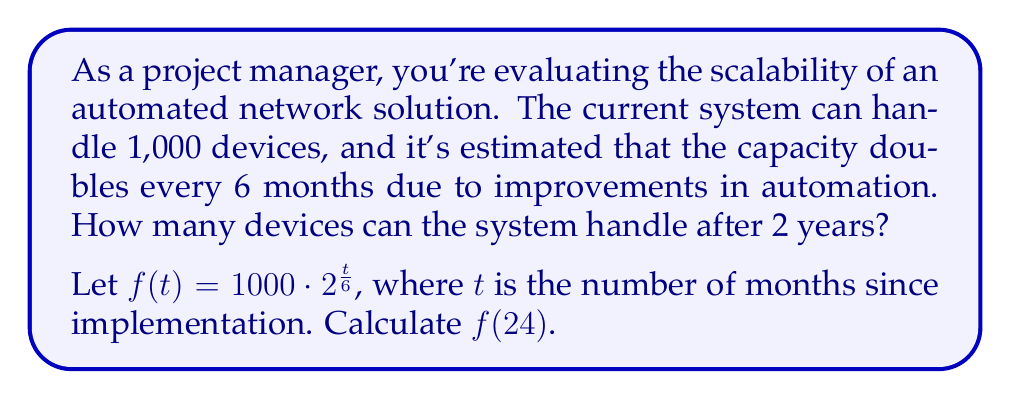Give your solution to this math problem. To solve this problem, we'll follow these steps:

1) We're given the function $f(t) = 1000 \cdot 2^{\frac{t}{6}}$, where:
   - 1000 is the initial capacity
   - 2 is the growth factor (capacity doubles)
   - $\frac{t}{6}$ represents the number of doubling periods (every 6 months)

2) We need to calculate $f(24)$, as 24 months = 2 years:

   $f(24) = 1000 \cdot 2^{\frac{24}{6}}$

3) Simplify the exponent:
   $f(24) = 1000 \cdot 2^4$

4) Calculate $2^4$:
   $2^4 = 16$

5) Multiply:
   $f(24) = 1000 \cdot 16 = 16,000$

Therefore, after 2 years, the automated network solution can handle 16,000 devices.
Answer: 16,000 devices 